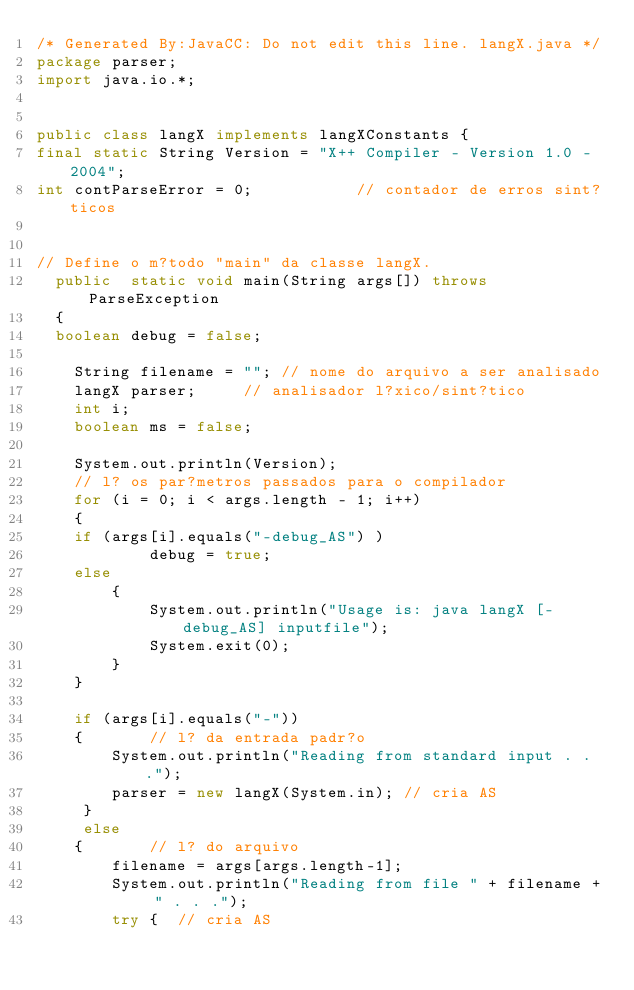<code> <loc_0><loc_0><loc_500><loc_500><_Java_>/* Generated By:JavaCC: Do not edit this line. langX.java */
package parser;
import java.io.*;


public class langX implements langXConstants {
final static String Version = "X++ Compiler - Version 1.0 - 2004";
int contParseError = 0;           // contador de erros sint?ticos


// Define o m?todo "main" da classe langX.  
  public  static void main(String args[]) throws ParseException
  {
  boolean debug = false;

    String filename = ""; // nome do arquivo a ser analisado
    langX parser;     // analisador l?xico/sint?tico
    int i;
    boolean ms = false;

    System.out.println(Version);
    // l? os par?metros passados para o compilador
    for (i = 0; i < args.length - 1; i++)
    {
    if (args[i].equals("-debug_AS") )
            debug = true;
    else
        {
            System.out.println("Usage is: java langX [-debug_AS] inputfile");
            System.exit(0);
        }
    }

    if (args[i].equals("-"))
    {       // l? da entrada padr?o      
        System.out.println("Reading from standard input . . .");
        parser = new langX(System.in); // cria AS
     }
     else
    {       // l? do arquivo
        filename = args[args.length-1];
        System.out.println("Reading from file " + filename + " . . .");
        try {  // cria AS</code> 